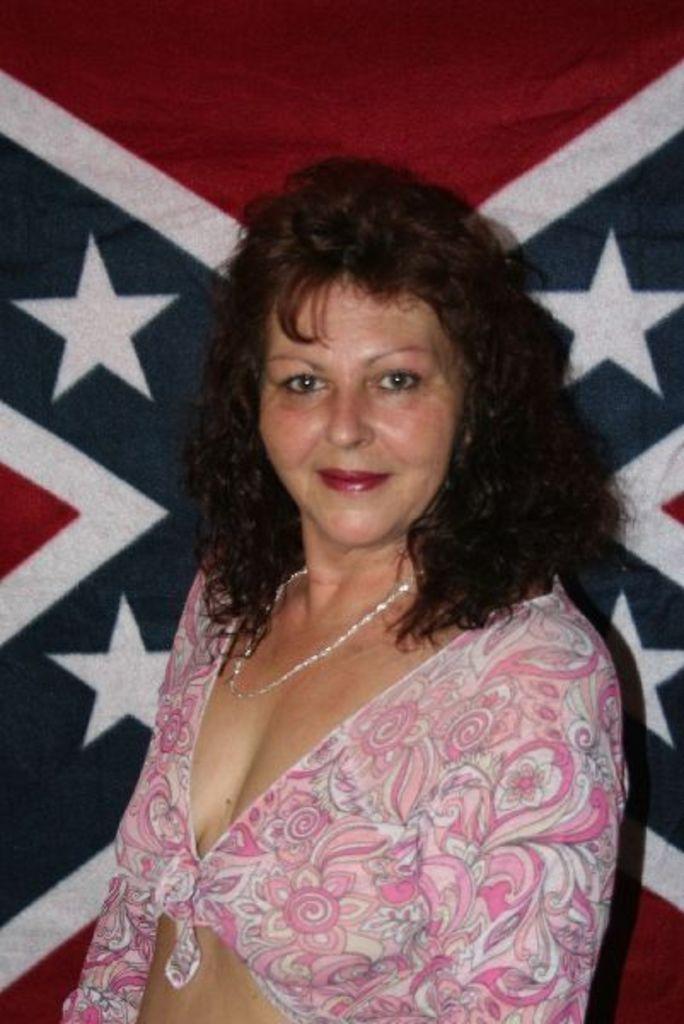Please provide a concise description of this image. In this picture there is a woman wearing pink dress and there is an object behind her. 